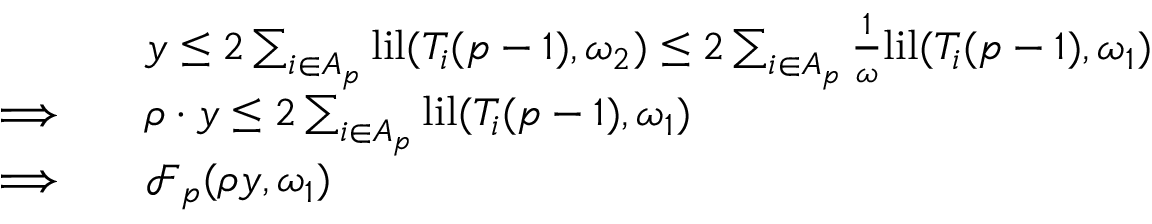Convert formula to latex. <formula><loc_0><loc_0><loc_500><loc_500>\begin{array} { r l } & { y \leq 2 \sum _ { i \in A _ { p } } l i l ( T _ { i } ( p - 1 ) , \omega _ { 2 } ) \leq 2 \sum _ { i \in A _ { p } } \frac { 1 } { \omega } l i l ( T _ { i } ( p - 1 ) , \omega _ { 1 } ) } \\ { \Longrightarrow \quad } & { \rho \cdot y \leq 2 \sum _ { i \in A _ { p } } l i l ( T _ { i } ( p - 1 ) , \omega _ { 1 } ) } \\ { \Longrightarrow \quad } & { \mathcal { F } _ { p } ( \rho y , \omega _ { 1 } ) } \end{array}</formula> 